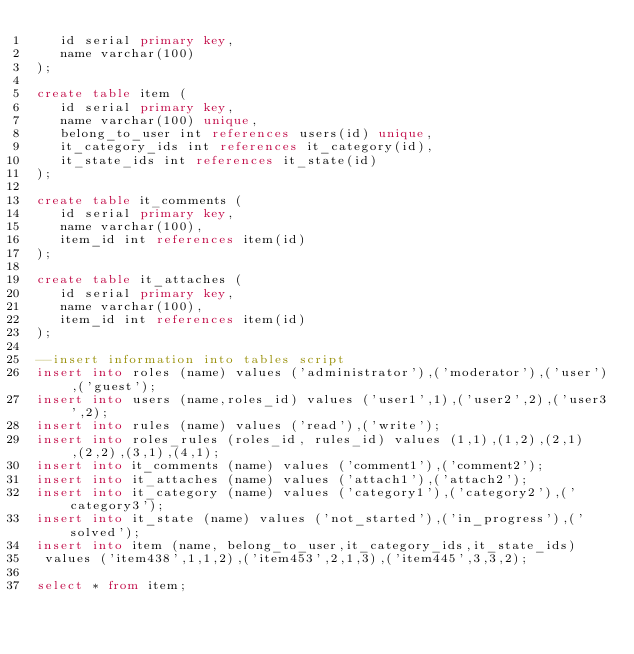Convert code to text. <code><loc_0><loc_0><loc_500><loc_500><_SQL_>   id serial primary key,
   name varchar(100)
);

create table item (
   id serial primary key,
   name varchar(100) unique,
   belong_to_user int references users(id) unique,
   it_category_ids int references it_category(id),
   it_state_ids int references it_state(id)
);

create table it_comments (
   id serial primary key,
   name varchar(100),
   item_id int references item(id)
);

create table it_attaches (
   id serial primary key,
   name varchar(100),
   item_id int references item(id)
);

--insert information into tables script
insert into roles (name) values ('administrator'),('moderator'),('user'),('guest');
insert into users (name,roles_id) values ('user1',1),('user2',2),('user3',2);
insert into rules (name) values ('read'),('write');
insert into roles_rules (roles_id, rules_id) values (1,1),(1,2),(2,1),(2,2),(3,1),(4,1);
insert into it_comments (name) values ('comment1'),('comment2');
insert into it_attaches (name) values ('attach1'),('attach2');
insert into it_category (name) values ('category1'),('category2'),('category3');
insert into it_state (name) values ('not_started'),('in_progress'),('solved');
insert into item (name, belong_to_user,it_category_ids,it_state_ids)
 values ('item438',1,1,2),('item453',2,1,3),('item445',3,3,2);

select * from item;</code> 